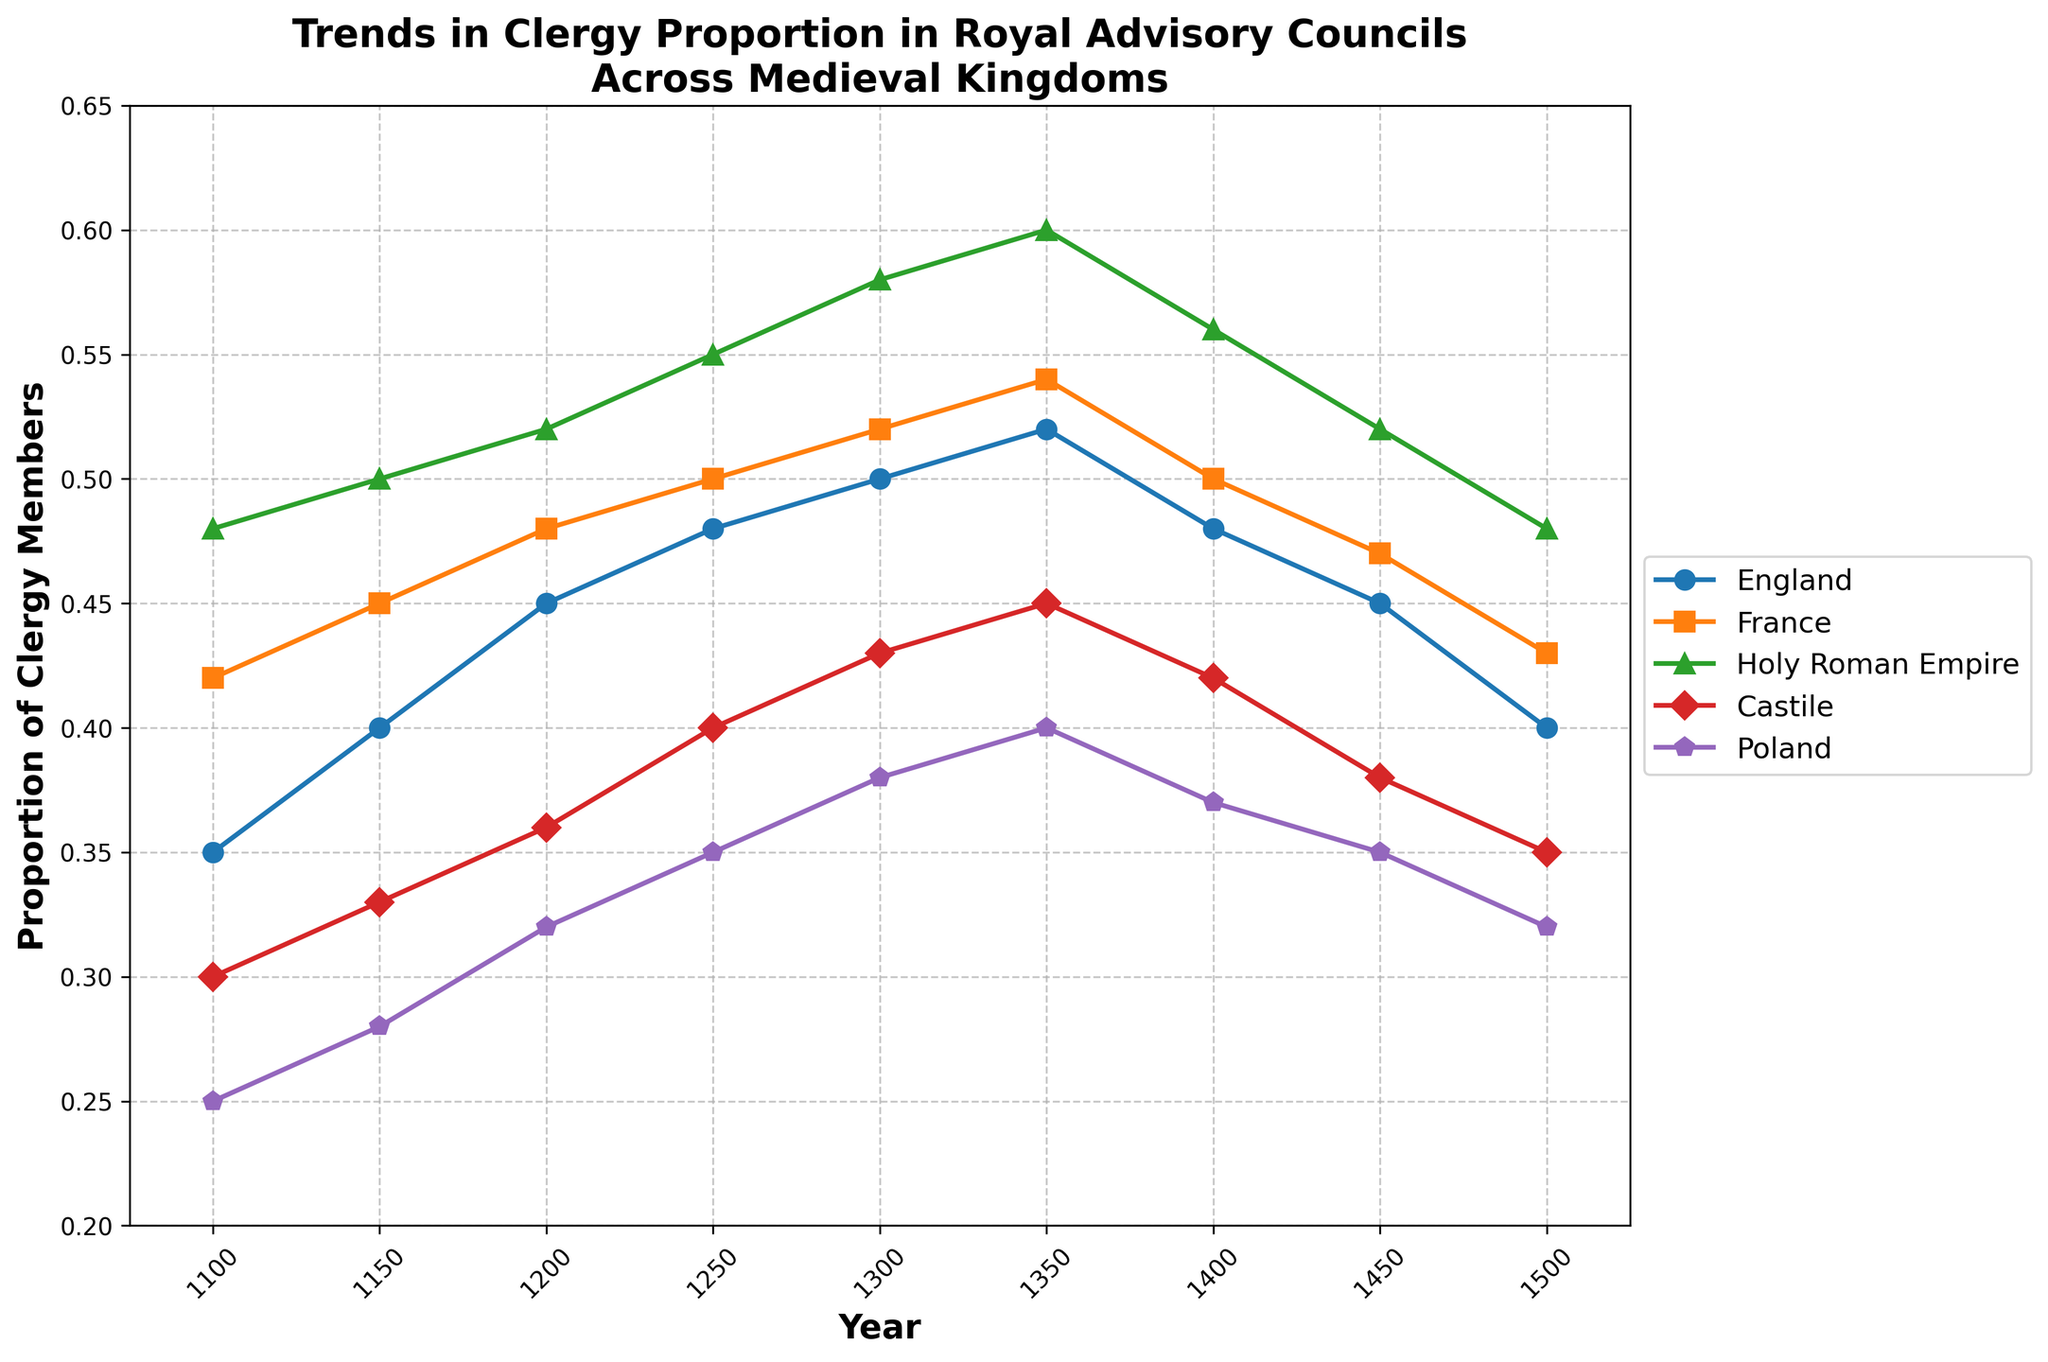What is the title of the figure? The title can be found at the top of the figure. It reads "Trends in Clergy Proportion in Royal Advisory Councils Across Medieval Kingdoms".
Answer: Trends in Clergy Proportion in Royal Advisory Councils Across Medieval Kingdoms Which kingdom had the highest proportion of clergy members in the year 1250? To find this, look at the 1250 marker on the x-axis and see which line reaches the highest point. The Holy Roman Empire has the highest proportion in that year.
Answer: Holy Roman Empire Between which years did the proportion of clergy members in the royal advisory council of Castile remain constant? Check the Castile line for flat segments. It remained constant between 1350 and 1400.
Answer: 1350 and 1400 In which kingdom did the proportion of clergy members increase throughout the entire period from 1100 to 1350? Trace each line from 1100 to 1350 and see if it always rises. England and France have increasing trends throughout this period.
Answer: England, France How many kingdoms experienced a decrease in the proportion of clergy members from 1350 to 1500? Identify the lines that show a downward trend from 1350 to 1500. England, France, Holy Roman Empire, Castile, and Poland all experienced a decrease.
Answer: Five What is the difference in the proportion of clergy members in the advisory council of Poland between 1100 and 1450? Subtract the proportion value of Poland at 1100 (0.25) from that at 1450 (0.35).
Answer: 0.10 During which period did the Holy Roman Empire see the most significant increase in the proportion of clergy members? Look for the steepest upward slope in the Holy Roman Empire's line. The most significant increase occurred between 1100 and 1350.
Answer: 1100 to 1350 Which kingdom had the least variation in the proportion of clergy members over the entire period? Identify the kingdom with the least vertical movement in its line. Castile shows the least variation as its line appears the most stable.
Answer: Castile Which two kingdoms showed a similar trend in the proportion of clergy members from 1100 to 1250? Compare the trends of the lines from 1100 to 1250. England and France show a similar upward trend in this period.
Answer: England and France What was the approximate average proportion of clergy members in the advisory councils across all kingdoms in the year 1200? Add the proportions of all five kingdoms in 1200 and divide by 5: (0.45 + 0.48 + 0.52 + 0.36 + 0.32) / 5 ≈ 0.426.
Answer: 0.426 